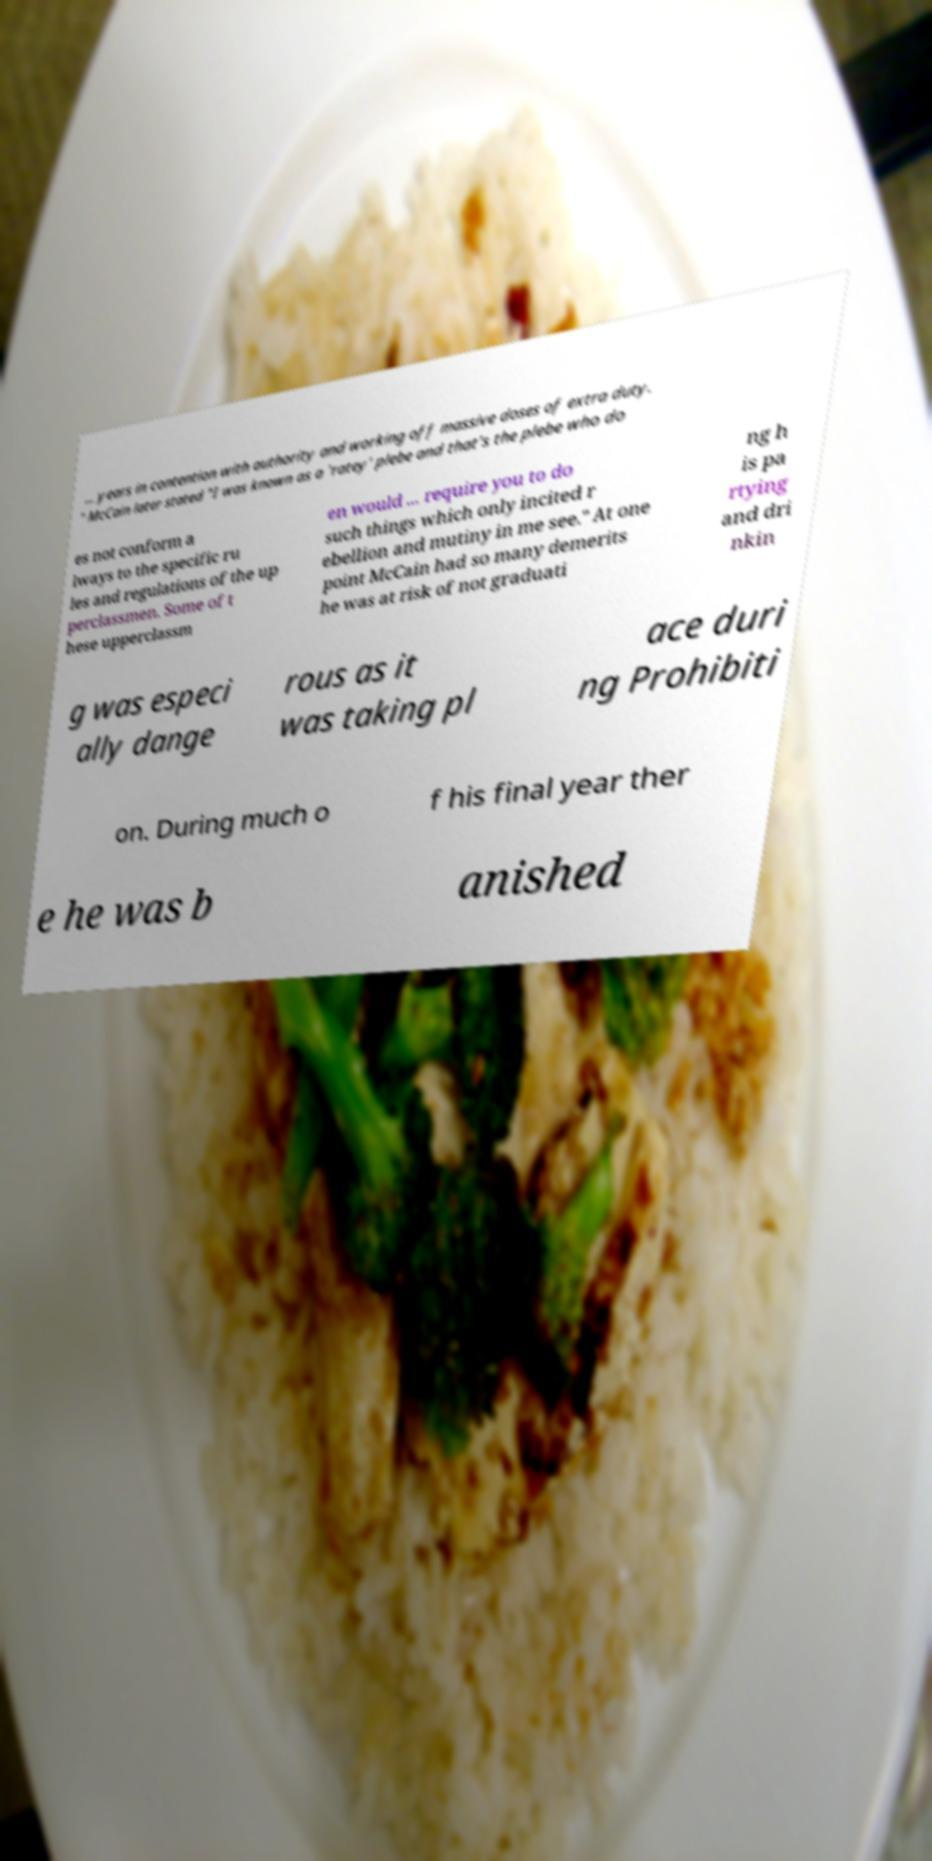Please read and relay the text visible in this image. What does it say? ... years in contention with authority and working off massive doses of extra duty. " McCain later stated "I was known as a 'ratey' plebe and that's the plebe who do es not conform a lways to the specific ru les and regulations of the up perclassmen. Some of t hese upperclassm en would ... require you to do such things which only incited r ebellion and mutiny in me see." At one point McCain had so many demerits he was at risk of not graduati ng h is pa rtying and dri nkin g was especi ally dange rous as it was taking pl ace duri ng Prohibiti on. During much o f his final year ther e he was b anished 